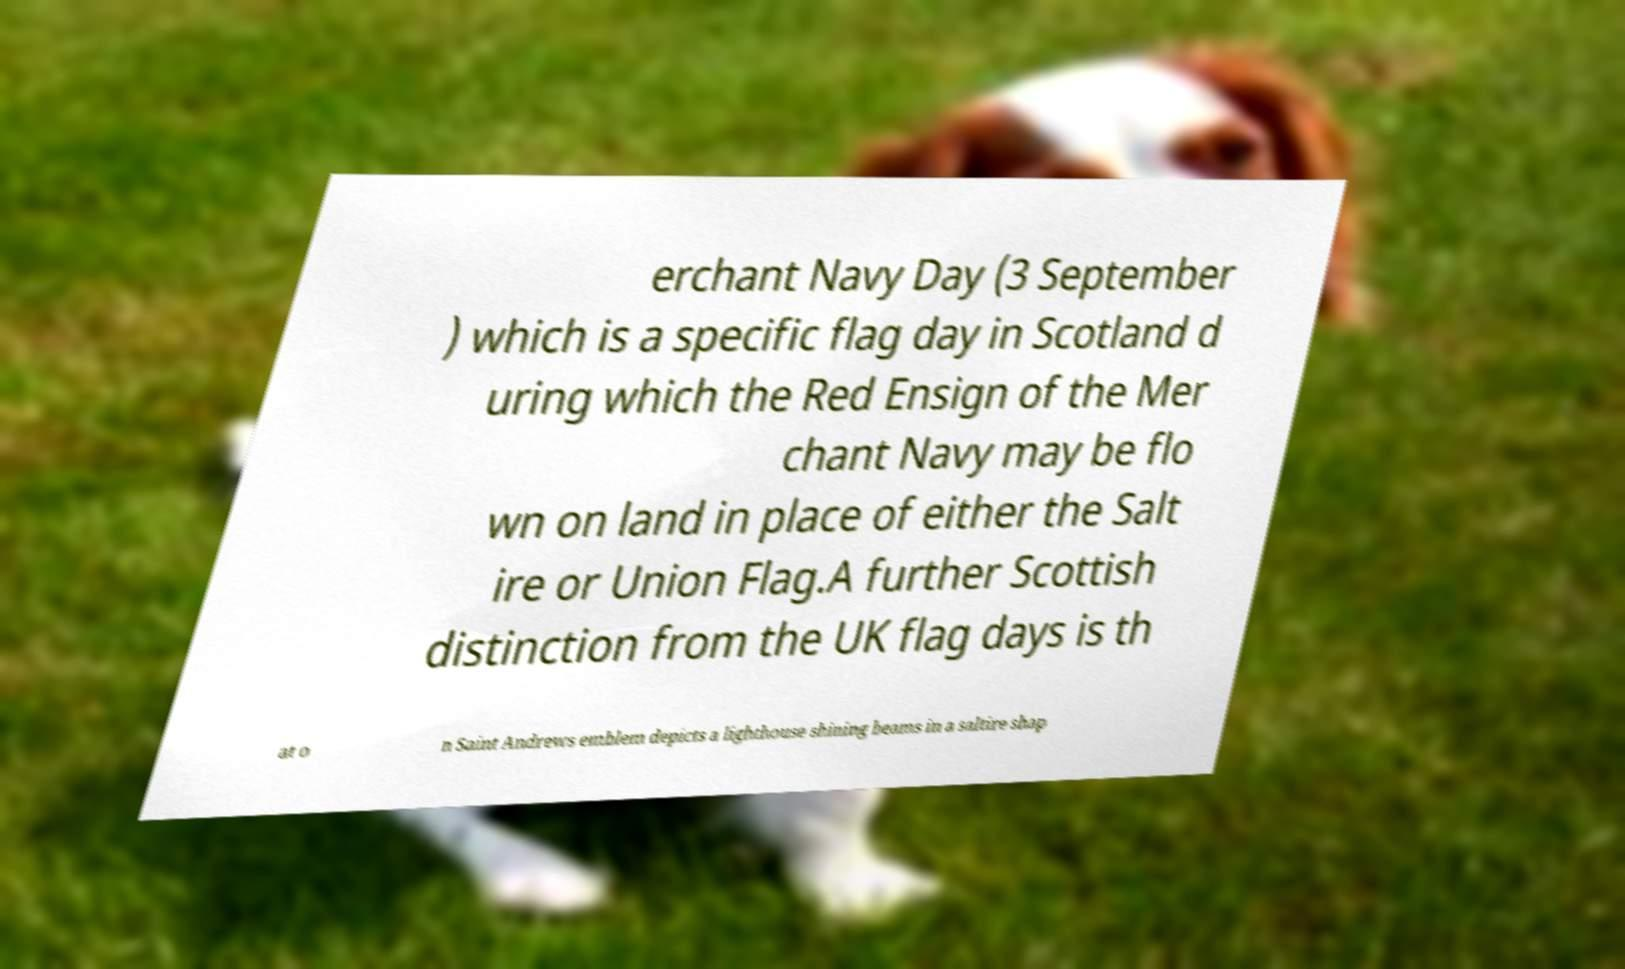Can you accurately transcribe the text from the provided image for me? erchant Navy Day (3 September ) which is a specific flag day in Scotland d uring which the Red Ensign of the Mer chant Navy may be flo wn on land in place of either the Salt ire or Union Flag.A further Scottish distinction from the UK flag days is th at o n Saint Andrews emblem depicts a lighthouse shining beams in a saltire shap 